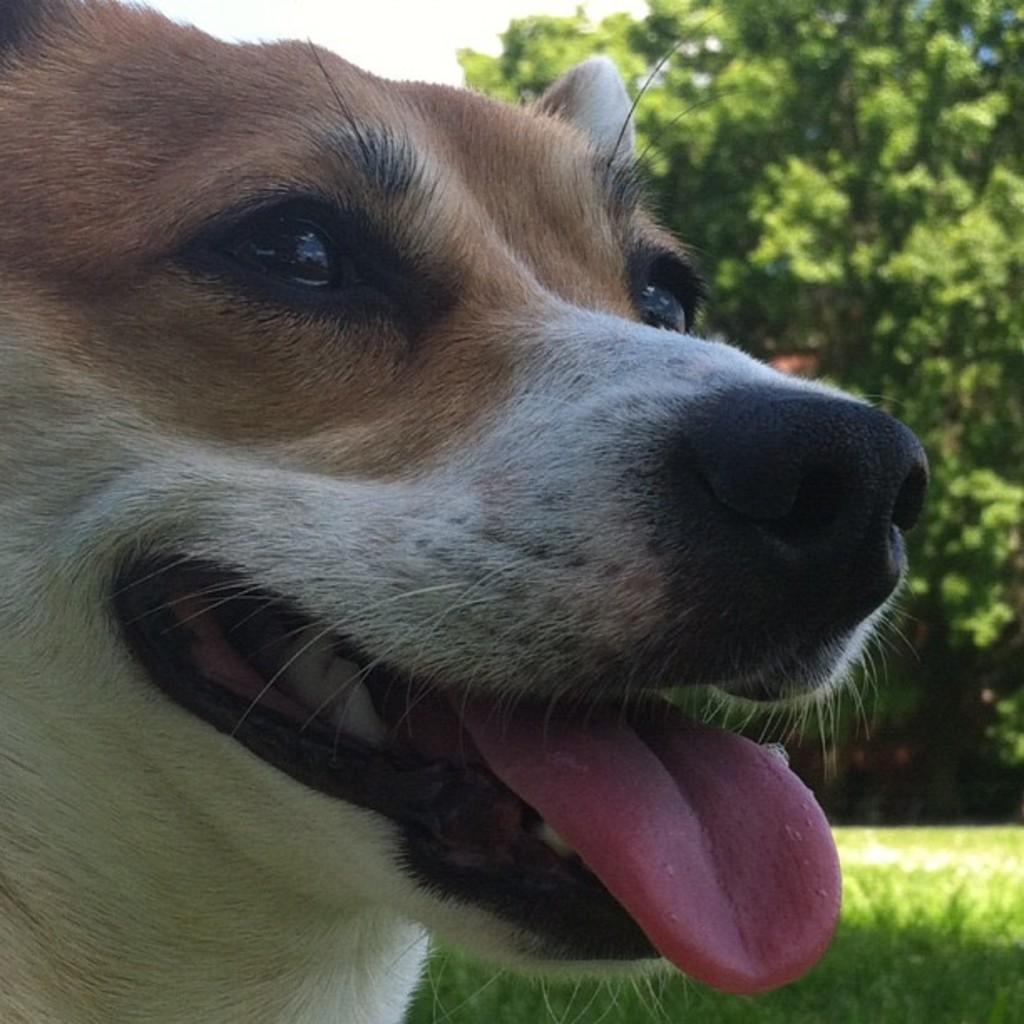How would you summarize this image in a sentence or two? In the center of the image we can see dogs face. In the background we can see grass, tree and sky. 